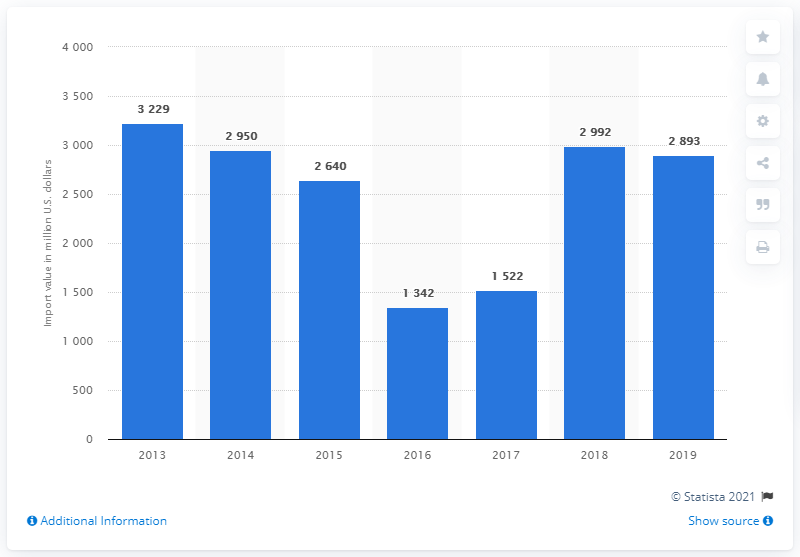List a handful of essential elements in this visual. In 2019, the import value of computers and peripheral equipment in Indonesia was approximately 2,893. 